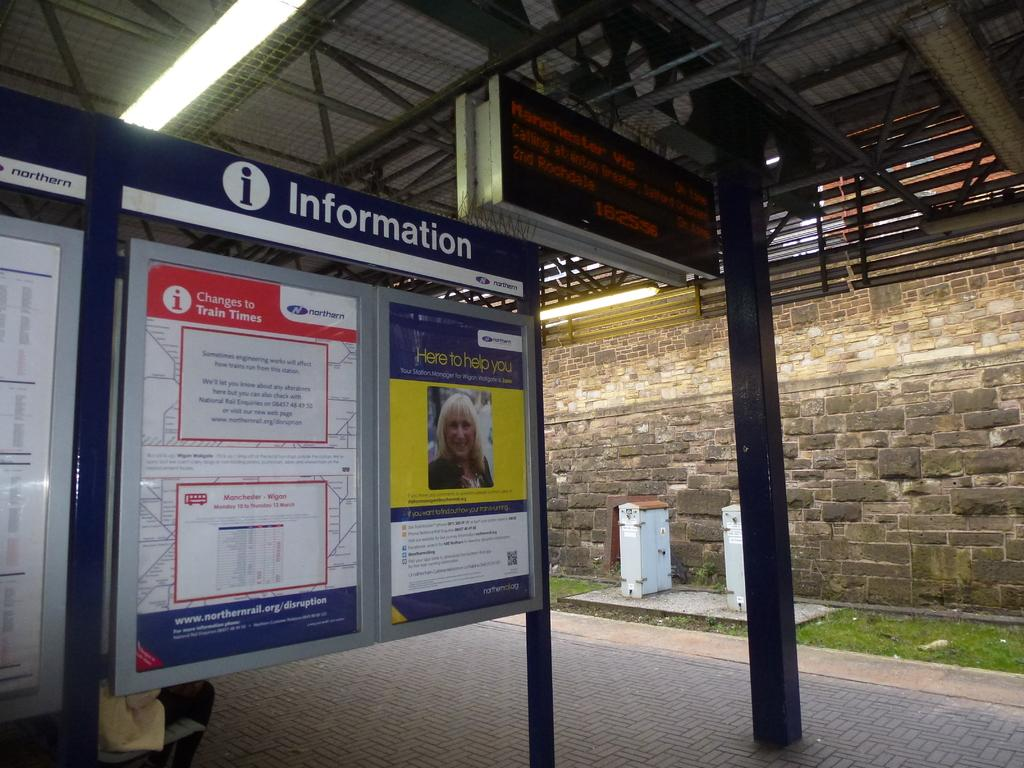<image>
Offer a succinct explanation of the picture presented. An information board sits under an electronic display board. 